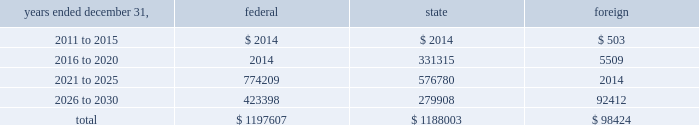American tower corporation and subsidiaries notes to consolidated financial statements the valuation allowance increased from $ 47.8 million as of december 31 , 2009 to $ 48.2 million as of december 31 , 2010 .
The increase was primarily due to valuation allowances on foreign loss carryforwards .
At december 31 , 2010 , the company has provided a valuation allowance of approximately $ 48.2 million which primarily relates to state net operating loss carryforwards , equity investments and foreign items .
The company has not provided a valuation allowance for the remaining deferred tax assets , primarily its federal net operating loss carryforwards , as management believes the company will have sufficient taxable income to realize these federal net operating loss carryforwards during the twenty-year tax carryforward period .
Valuation allowances may be reversed if related deferred tax assets are deemed realizable based on changes in facts and circumstances relevant to the assets 2019 recoverability .
The recoverability of the company 2019s remaining net deferred tax asset has been assessed utilizing projections based on its current operations .
The projections show a significant decrease in depreciation in the later years of the carryforward period as a result of a significant portion of its assets being fully depreciated during the first fifteen years of the carryforward period .
Accordingly , the recoverability of the net deferred tax asset is not dependent on material improvements to operations , material asset sales or other non-routine transactions .
Based on its current outlook of future taxable income during the carryforward period , management believes that the net deferred tax asset will be realized .
The company 2019s deferred tax assets as of december 31 , 2010 and 2009 in the table above do not include $ 122.1 million and $ 113.9 million , respectively , of excess tax benefits from the exercises of employee stock options that are a component of net operating losses .
Total stockholders 2019 equity as of december 31 , 2010 will be increased by $ 122.1 million if and when any such excess tax benefits are ultimately realized .
At december 31 , 2010 , the company had net federal and state operating loss carryforwards available to reduce future federal and state taxable income of approximately $ 1.2 billion , including losses related to employee stock options of $ 0.3 billion .
If not utilized , the company 2019s net operating loss carryforwards expire as follows ( in thousands ) : .
In addition , the company has mexican tax credits of $ 5.2 million which if not utilized would expire in 2017. .
What portion of the total net operating loss carryforwards is state related? 
Computations: (1188003 / ((1197607 + 1188003) + 98424))
Answer: 0.47826. American tower corporation and subsidiaries notes to consolidated financial statements the valuation allowance increased from $ 47.8 million as of december 31 , 2009 to $ 48.2 million as of december 31 , 2010 .
The increase was primarily due to valuation allowances on foreign loss carryforwards .
At december 31 , 2010 , the company has provided a valuation allowance of approximately $ 48.2 million which primarily relates to state net operating loss carryforwards , equity investments and foreign items .
The company has not provided a valuation allowance for the remaining deferred tax assets , primarily its federal net operating loss carryforwards , as management believes the company will have sufficient taxable income to realize these federal net operating loss carryforwards during the twenty-year tax carryforward period .
Valuation allowances may be reversed if related deferred tax assets are deemed realizable based on changes in facts and circumstances relevant to the assets 2019 recoverability .
The recoverability of the company 2019s remaining net deferred tax asset has been assessed utilizing projections based on its current operations .
The projections show a significant decrease in depreciation in the later years of the carryforward period as a result of a significant portion of its assets being fully depreciated during the first fifteen years of the carryforward period .
Accordingly , the recoverability of the net deferred tax asset is not dependent on material improvements to operations , material asset sales or other non-routine transactions .
Based on its current outlook of future taxable income during the carryforward period , management believes that the net deferred tax asset will be realized .
The company 2019s deferred tax assets as of december 31 , 2010 and 2009 in the table above do not include $ 122.1 million and $ 113.9 million , respectively , of excess tax benefits from the exercises of employee stock options that are a component of net operating losses .
Total stockholders 2019 equity as of december 31 , 2010 will be increased by $ 122.1 million if and when any such excess tax benefits are ultimately realized .
At december 31 , 2010 , the company had net federal and state operating loss carryforwards available to reduce future federal and state taxable income of approximately $ 1.2 billion , including losses related to employee stock options of $ 0.3 billion .
If not utilized , the company 2019s net operating loss carryforwards expire as follows ( in thousands ) : .
In addition , the company has mexican tax credits of $ 5.2 million which if not utilized would expire in 2017. .
At december 31 , 2010 what was the percent of the total net operating loss carry forwards set to expire between 2021 and 2025? 
Computations: (774209 / 1197607)
Answer: 0.64646. 